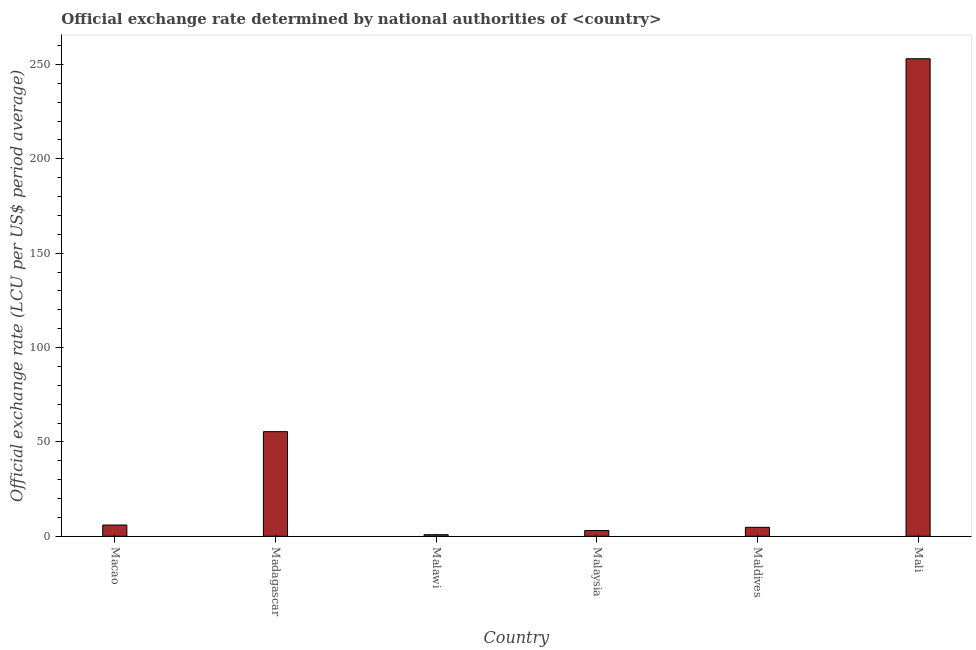What is the title of the graph?
Provide a succinct answer. Official exchange rate determined by national authorities of <country>. What is the label or title of the Y-axis?
Offer a very short reply. Official exchange rate (LCU per US$ period average). What is the official exchange rate in Maldives?
Provide a succinct answer. 4.73. Across all countries, what is the maximum official exchange rate?
Keep it short and to the point. 253.03. Across all countries, what is the minimum official exchange rate?
Provide a succinct answer. 0.83. In which country was the official exchange rate maximum?
Keep it short and to the point. Mali. In which country was the official exchange rate minimum?
Offer a very short reply. Malawi. What is the sum of the official exchange rate?
Ensure brevity in your answer.  323.02. What is the difference between the official exchange rate in Madagascar and Malaysia?
Your answer should be compact. 52.37. What is the average official exchange rate per country?
Ensure brevity in your answer.  53.84. What is the median official exchange rate?
Give a very brief answer. 5.34. In how many countries, is the official exchange rate greater than 220 ?
Offer a very short reply. 1. What is the ratio of the official exchange rate in Malaysia to that in Mali?
Offer a terse response. 0.01. Is the difference between the official exchange rate in Macao and Madagascar greater than the difference between any two countries?
Provide a short and direct response. No. What is the difference between the highest and the second highest official exchange rate?
Keep it short and to the point. 197.6. What is the difference between the highest and the lowest official exchange rate?
Make the answer very short. 252.2. In how many countries, is the official exchange rate greater than the average official exchange rate taken over all countries?
Keep it short and to the point. 2. What is the Official exchange rate (LCU per US$ period average) in Macao?
Keep it short and to the point. 5.95. What is the Official exchange rate (LCU per US$ period average) in Madagascar?
Your response must be concise. 55.43. What is the Official exchange rate (LCU per US$ period average) in Malawi?
Your answer should be compact. 0.83. What is the Official exchange rate (LCU per US$ period average) of Malaysia?
Offer a terse response. 3.05. What is the Official exchange rate (LCU per US$ period average) of Maldives?
Offer a very short reply. 4.73. What is the Official exchange rate (LCU per US$ period average) in Mali?
Keep it short and to the point. 253.03. What is the difference between the Official exchange rate (LCU per US$ period average) in Macao and Madagascar?
Give a very brief answer. -49.48. What is the difference between the Official exchange rate (LCU per US$ period average) in Macao and Malawi?
Your response must be concise. 5.12. What is the difference between the Official exchange rate (LCU per US$ period average) in Macao and Malaysia?
Your answer should be compact. 2.9. What is the difference between the Official exchange rate (LCU per US$ period average) in Macao and Maldives?
Offer a terse response. 1.21. What is the difference between the Official exchange rate (LCU per US$ period average) in Macao and Mali?
Offer a very short reply. -247.08. What is the difference between the Official exchange rate (LCU per US$ period average) in Madagascar and Malawi?
Make the answer very short. 54.6. What is the difference between the Official exchange rate (LCU per US$ period average) in Madagascar and Malaysia?
Keep it short and to the point. 52.37. What is the difference between the Official exchange rate (LCU per US$ period average) in Madagascar and Maldives?
Your response must be concise. 50.69. What is the difference between the Official exchange rate (LCU per US$ period average) in Madagascar and Mali?
Give a very brief answer. -197.6. What is the difference between the Official exchange rate (LCU per US$ period average) in Malawi and Malaysia?
Your response must be concise. -2.22. What is the difference between the Official exchange rate (LCU per US$ period average) in Malawi and Maldives?
Your response must be concise. -3.9. What is the difference between the Official exchange rate (LCU per US$ period average) in Malawi and Mali?
Give a very brief answer. -252.2. What is the difference between the Official exchange rate (LCU per US$ period average) in Malaysia and Maldives?
Ensure brevity in your answer.  -1.68. What is the difference between the Official exchange rate (LCU per US$ period average) in Malaysia and Mali?
Make the answer very short. -249.97. What is the difference between the Official exchange rate (LCU per US$ period average) in Maldives and Mali?
Ensure brevity in your answer.  -248.29. What is the ratio of the Official exchange rate (LCU per US$ period average) in Macao to that in Madagascar?
Keep it short and to the point. 0.11. What is the ratio of the Official exchange rate (LCU per US$ period average) in Macao to that in Malawi?
Your response must be concise. 7.16. What is the ratio of the Official exchange rate (LCU per US$ period average) in Macao to that in Malaysia?
Your answer should be compact. 1.95. What is the ratio of the Official exchange rate (LCU per US$ period average) in Macao to that in Maldives?
Offer a very short reply. 1.26. What is the ratio of the Official exchange rate (LCU per US$ period average) in Macao to that in Mali?
Offer a terse response. 0.02. What is the ratio of the Official exchange rate (LCU per US$ period average) in Madagascar to that in Malawi?
Provide a short and direct response. 66.71. What is the ratio of the Official exchange rate (LCU per US$ period average) in Madagascar to that in Malaysia?
Provide a short and direct response. 18.16. What is the ratio of the Official exchange rate (LCU per US$ period average) in Madagascar to that in Maldives?
Ensure brevity in your answer.  11.71. What is the ratio of the Official exchange rate (LCU per US$ period average) in Madagascar to that in Mali?
Offer a very short reply. 0.22. What is the ratio of the Official exchange rate (LCU per US$ period average) in Malawi to that in Malaysia?
Your response must be concise. 0.27. What is the ratio of the Official exchange rate (LCU per US$ period average) in Malawi to that in Maldives?
Your response must be concise. 0.18. What is the ratio of the Official exchange rate (LCU per US$ period average) in Malawi to that in Mali?
Your response must be concise. 0. What is the ratio of the Official exchange rate (LCU per US$ period average) in Malaysia to that in Maldives?
Offer a terse response. 0.65. What is the ratio of the Official exchange rate (LCU per US$ period average) in Malaysia to that in Mali?
Your response must be concise. 0.01. What is the ratio of the Official exchange rate (LCU per US$ period average) in Maldives to that in Mali?
Your response must be concise. 0.02. 